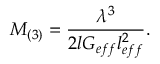Convert formula to latex. <formula><loc_0><loc_0><loc_500><loc_500>M _ { ( 3 ) } = \frac { \lambda ^ { 3 } } { 2 l G _ { e f f } l _ { e f f } ^ { 2 } } .</formula> 